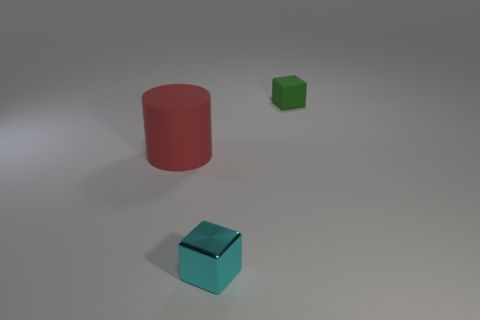How big is the block left of the matte cube?
Provide a succinct answer. Small. Is there any other thing that is the same size as the cyan metal block?
Offer a terse response. Yes. The thing that is behind the shiny cube and left of the small matte thing is what color?
Your response must be concise. Red. Do the tiny block that is behind the small cyan metal cube and the cylinder have the same material?
Offer a terse response. Yes. There is a small shiny thing; does it have the same color as the object that is on the right side of the metallic thing?
Your answer should be very brief. No. There is a green matte thing; are there any tiny things behind it?
Provide a short and direct response. No. There is a rubber object that is in front of the small green block; is its size the same as the block in front of the tiny green cube?
Your answer should be very brief. No. Is there another cyan cube that has the same size as the cyan metallic block?
Provide a succinct answer. No. Do the matte object that is to the left of the cyan metallic block and the tiny green rubber object have the same shape?
Provide a short and direct response. No. There is a small object that is on the left side of the green block; what is it made of?
Your answer should be very brief. Metal. 